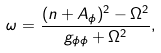Convert formula to latex. <formula><loc_0><loc_0><loc_500><loc_500>\omega = \frac { ( n + A _ { \phi } ) ^ { 2 } - \Omega ^ { 2 } } { g _ { \phi \phi } + \Omega ^ { 2 } } ,</formula> 